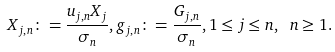<formula> <loc_0><loc_0><loc_500><loc_500>X _ { j , n } \colon = \frac { u _ { j , n } X _ { j } } { \sigma _ { n } } , g _ { j , n } \colon = \frac { G _ { j , n } } { \sigma _ { n } } , 1 \leq j \leq n , \ n \geq 1 .</formula> 